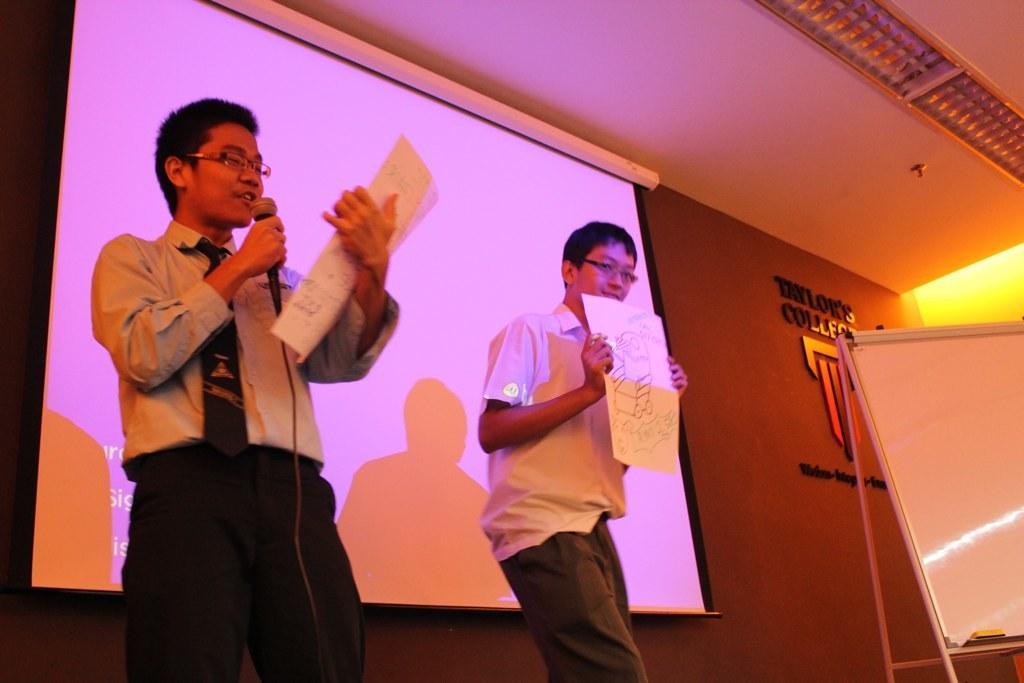Can you describe this image briefly? In this image we can see a boy wearing specs. And he is holding mic and paper. There is another boy wearing specs and holding paper. In the back there is screen on the wall. Also there is text and logo on the wall. And there is a board with stand. On the ceiling we can see lights. 